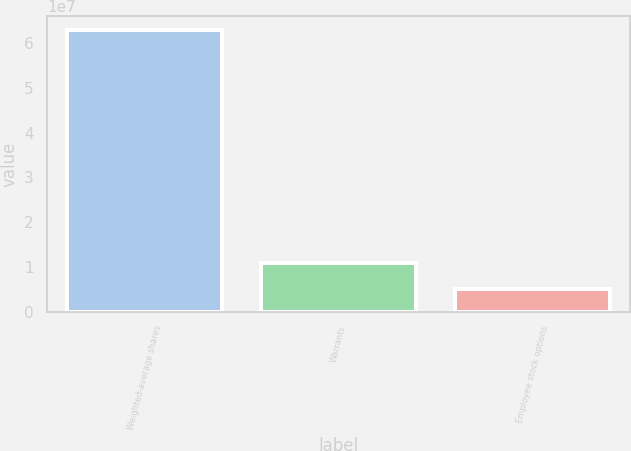<chart> <loc_0><loc_0><loc_500><loc_500><bar_chart><fcel>Weighted-average shares<fcel>Warrants<fcel>Employee stock options<nl><fcel>6.2884e+07<fcel>1.09018e+07<fcel>5.126e+06<nl></chart> 